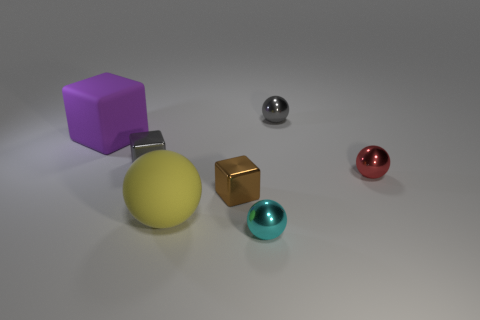What number of other objects are the same shape as the brown shiny thing?
Ensure brevity in your answer.  2. Are the red ball and the big yellow object made of the same material?
Offer a very short reply. No. What material is the big object that is the same shape as the tiny brown thing?
Your answer should be compact. Rubber. Is the number of purple things in front of the small gray metallic cube less than the number of purple objects?
Your answer should be compact. Yes. How many yellow things are behind the small cyan metallic thing?
Ensure brevity in your answer.  1. Does the big matte object that is right of the gray block have the same shape as the matte object left of the tiny gray metallic cube?
Provide a succinct answer. No. The shiny thing that is both right of the tiny cyan metal thing and in front of the purple cube has what shape?
Your answer should be compact. Sphere. What size is the red ball that is made of the same material as the small gray block?
Provide a short and direct response. Small. Are there fewer shiny blocks than large spheres?
Give a very brief answer. No. What material is the small thing that is to the left of the yellow thing that is in front of the tiny gray object on the left side of the big yellow object made of?
Your answer should be compact. Metal. 